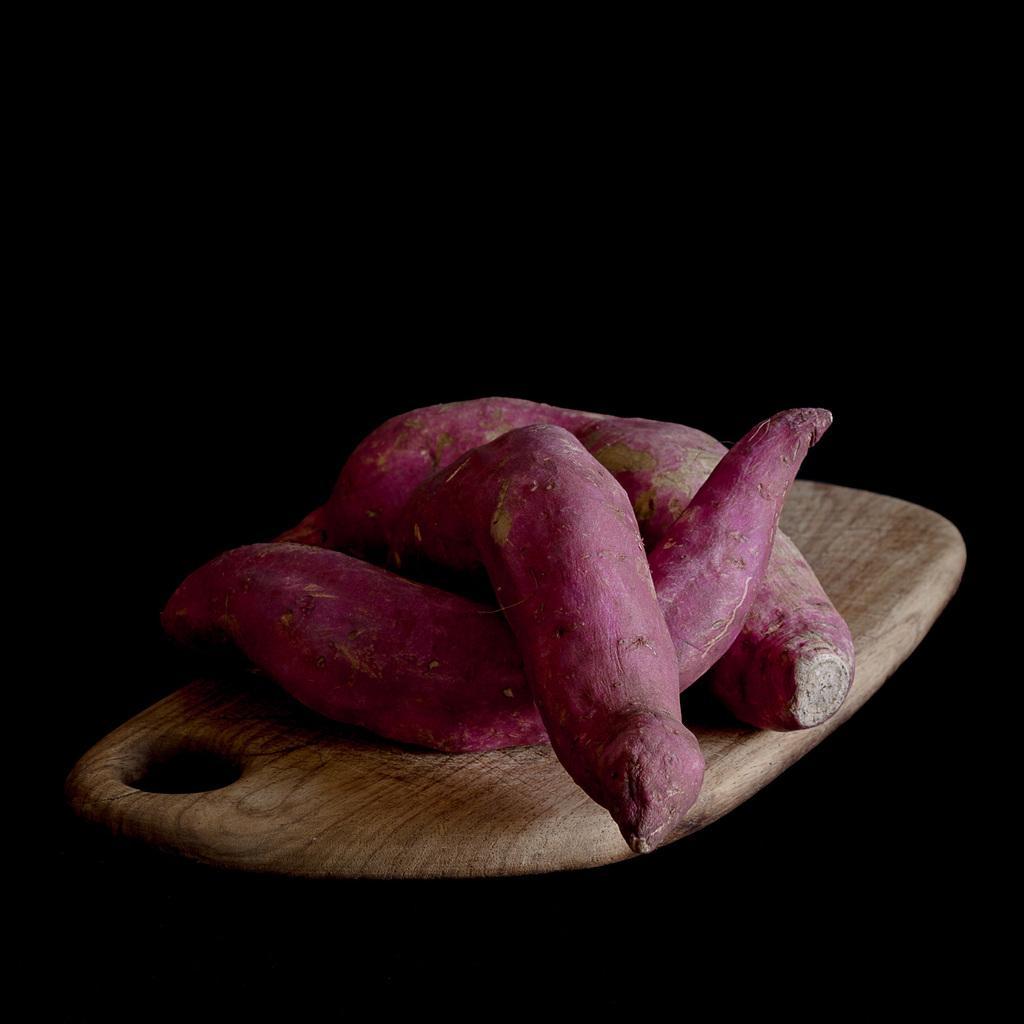Can you describe this image briefly? These are the sweet potatoes on a wooden board. 